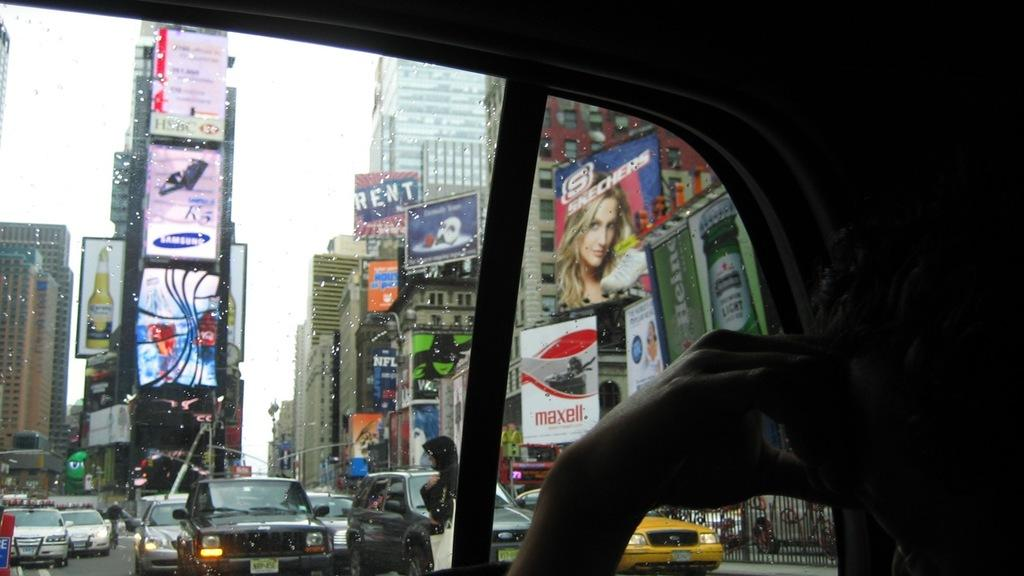<image>
Give a short and clear explanation of the subsequent image. A billboard for the musical RENT is up with many other billboards. 